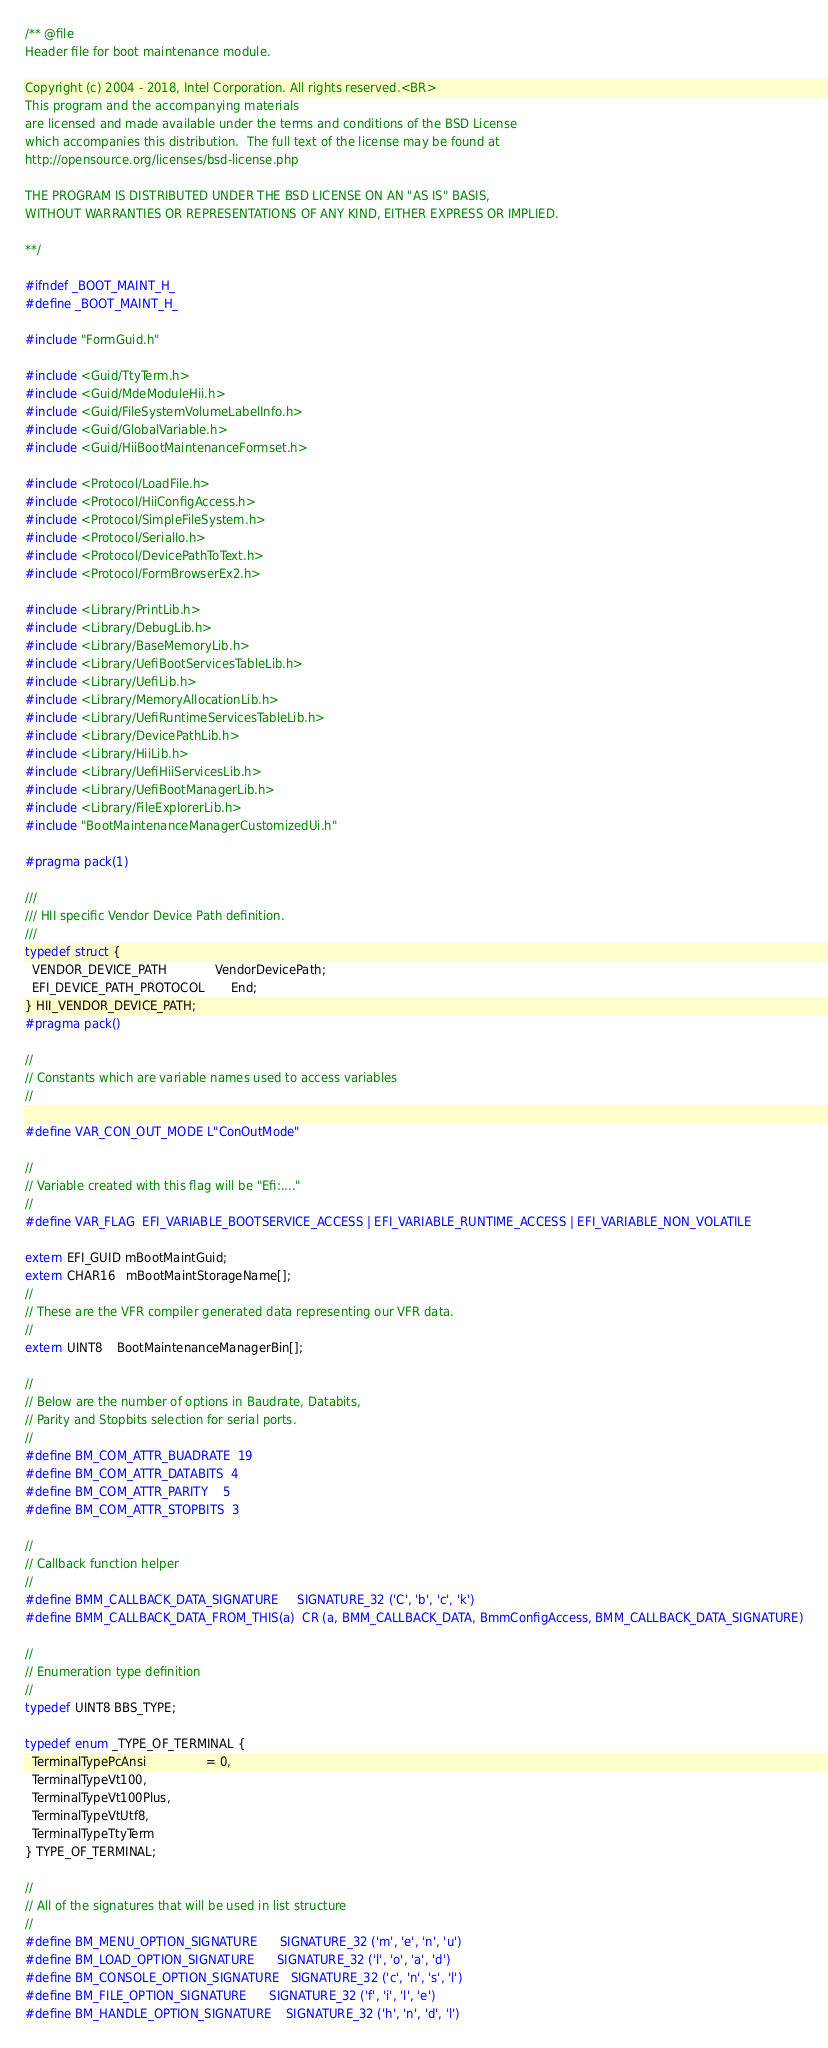Convert code to text. <code><loc_0><loc_0><loc_500><loc_500><_C_>/** @file
Header file for boot maintenance module.

Copyright (c) 2004 - 2018, Intel Corporation. All rights reserved.<BR>
This program and the accompanying materials
are licensed and made available under the terms and conditions of the BSD License
which accompanies this distribution.  The full text of the license may be found at
http://opensource.org/licenses/bsd-license.php

THE PROGRAM IS DISTRIBUTED UNDER THE BSD LICENSE ON AN "AS IS" BASIS,
WITHOUT WARRANTIES OR REPRESENTATIONS OF ANY KIND, EITHER EXPRESS OR IMPLIED.

**/

#ifndef _BOOT_MAINT_H_
#define _BOOT_MAINT_H_

#include "FormGuid.h"

#include <Guid/TtyTerm.h>
#include <Guid/MdeModuleHii.h>
#include <Guid/FileSystemVolumeLabelInfo.h>
#include <Guid/GlobalVariable.h>
#include <Guid/HiiBootMaintenanceFormset.h>

#include <Protocol/LoadFile.h>
#include <Protocol/HiiConfigAccess.h>
#include <Protocol/SimpleFileSystem.h>
#include <Protocol/SerialIo.h>
#include <Protocol/DevicePathToText.h>
#include <Protocol/FormBrowserEx2.h>

#include <Library/PrintLib.h>
#include <Library/DebugLib.h>
#include <Library/BaseMemoryLib.h>
#include <Library/UefiBootServicesTableLib.h>
#include <Library/UefiLib.h>
#include <Library/MemoryAllocationLib.h>
#include <Library/UefiRuntimeServicesTableLib.h>
#include <Library/DevicePathLib.h>
#include <Library/HiiLib.h>
#include <Library/UefiHiiServicesLib.h>
#include <Library/UefiBootManagerLib.h>
#include <Library/FileExplorerLib.h>
#include "BootMaintenanceManagerCustomizedUi.h"

#pragma pack(1)

///
/// HII specific Vendor Device Path definition.
///
typedef struct {
  VENDOR_DEVICE_PATH             VendorDevicePath;
  EFI_DEVICE_PATH_PROTOCOL       End;
} HII_VENDOR_DEVICE_PATH;
#pragma pack()

//
// Constants which are variable names used to access variables
//

#define VAR_CON_OUT_MODE L"ConOutMode"

//
// Variable created with this flag will be "Efi:...."
//
#define VAR_FLAG  EFI_VARIABLE_BOOTSERVICE_ACCESS | EFI_VARIABLE_RUNTIME_ACCESS | EFI_VARIABLE_NON_VOLATILE

extern EFI_GUID mBootMaintGuid;
extern CHAR16   mBootMaintStorageName[];
//
// These are the VFR compiler generated data representing our VFR data.
//
extern UINT8    BootMaintenanceManagerBin[];

//
// Below are the number of options in Baudrate, Databits,
// Parity and Stopbits selection for serial ports.
//
#define BM_COM_ATTR_BUADRATE  19
#define BM_COM_ATTR_DATABITS  4
#define BM_COM_ATTR_PARITY    5
#define BM_COM_ATTR_STOPBITS  3

//
// Callback function helper
//
#define BMM_CALLBACK_DATA_SIGNATURE     SIGNATURE_32 ('C', 'b', 'c', 'k')
#define BMM_CALLBACK_DATA_FROM_THIS(a)  CR (a, BMM_CALLBACK_DATA, BmmConfigAccess, BMM_CALLBACK_DATA_SIGNATURE)

//
// Enumeration type definition
//
typedef UINT8 BBS_TYPE;

typedef enum _TYPE_OF_TERMINAL {
  TerminalTypePcAnsi                = 0,
  TerminalTypeVt100,
  TerminalTypeVt100Plus,
  TerminalTypeVtUtf8,
  TerminalTypeTtyTerm
} TYPE_OF_TERMINAL;

//
// All of the signatures that will be used in list structure
//
#define BM_MENU_OPTION_SIGNATURE      SIGNATURE_32 ('m', 'e', 'n', 'u')
#define BM_LOAD_OPTION_SIGNATURE      SIGNATURE_32 ('l', 'o', 'a', 'd')
#define BM_CONSOLE_OPTION_SIGNATURE   SIGNATURE_32 ('c', 'n', 's', 'l')
#define BM_FILE_OPTION_SIGNATURE      SIGNATURE_32 ('f', 'i', 'l', 'e')
#define BM_HANDLE_OPTION_SIGNATURE    SIGNATURE_32 ('h', 'n', 'd', 'l')</code> 